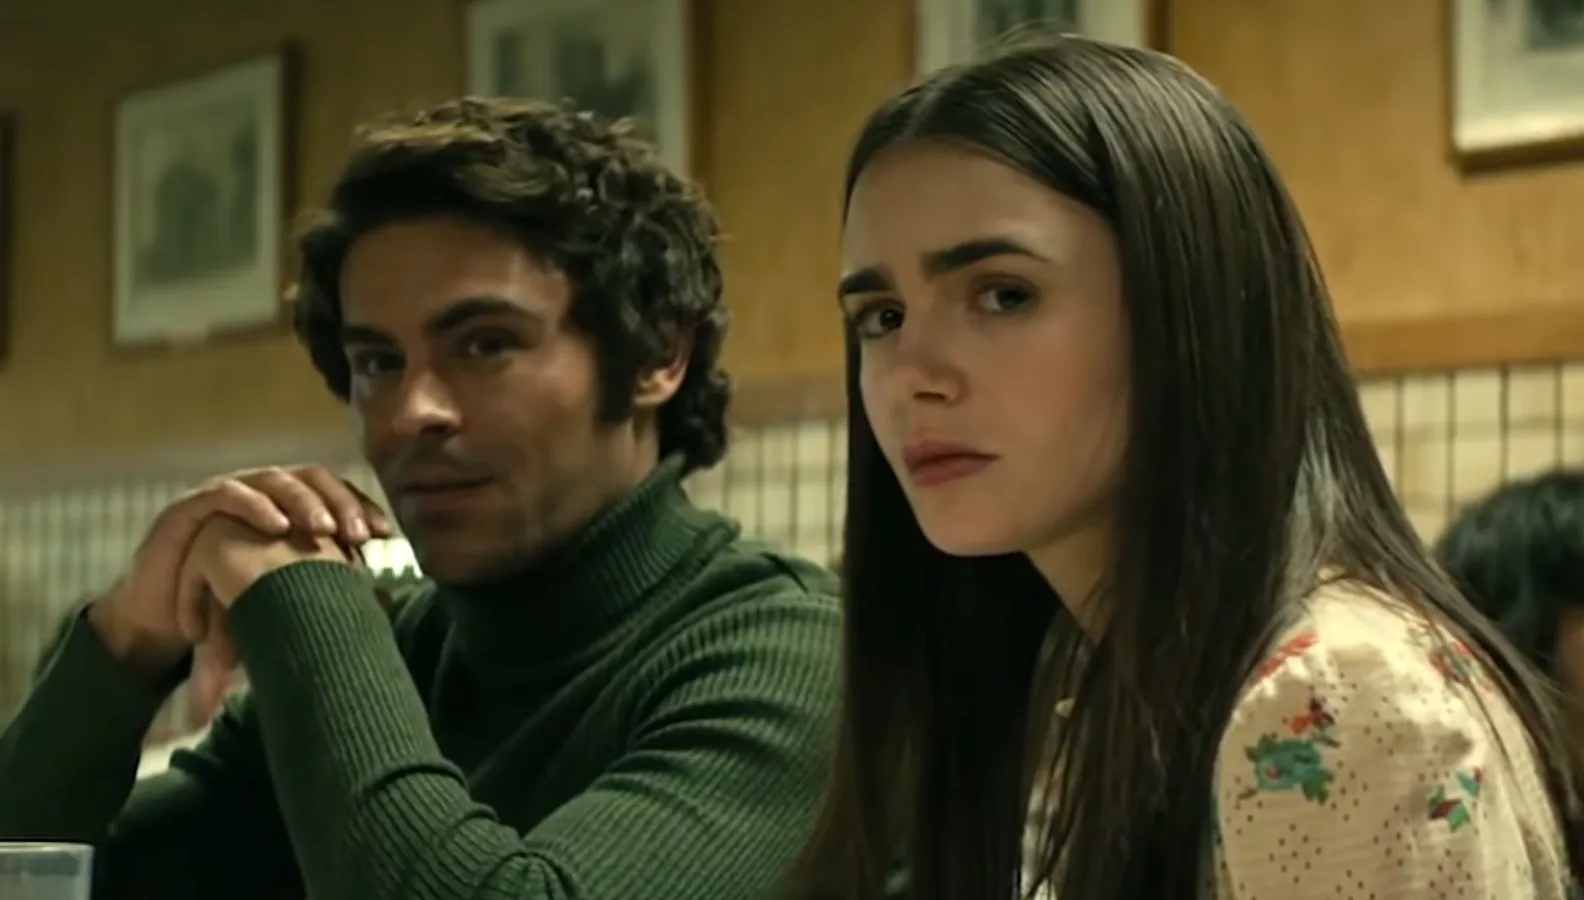Explain the visual content of the image in great detail. The image captures two individuals in a moody, intimate diner setting. A person, appearing to be male, rests on the left, donning a textured, deep green turtleneck sweater that contrasts with the warm yet subdued tones of the setting. Poised with an introspective mien, he props his chin on his hand, directing his thoughtful gaze slightly off-camera. The individual to the right, apparently female, is clad in a white blouse with a delicate floral design, her long, dark hair draped smoothly over her shoulders. Her eyes, echoing a similar off-camera focus, and her half-parted lips suggest a moment caught between words, possibly a pause in a poignant conversation. The image's composition, the actor's expressions, and the dimly lit background converge to evoke a narrative rich with unspoken tension and complexity. 